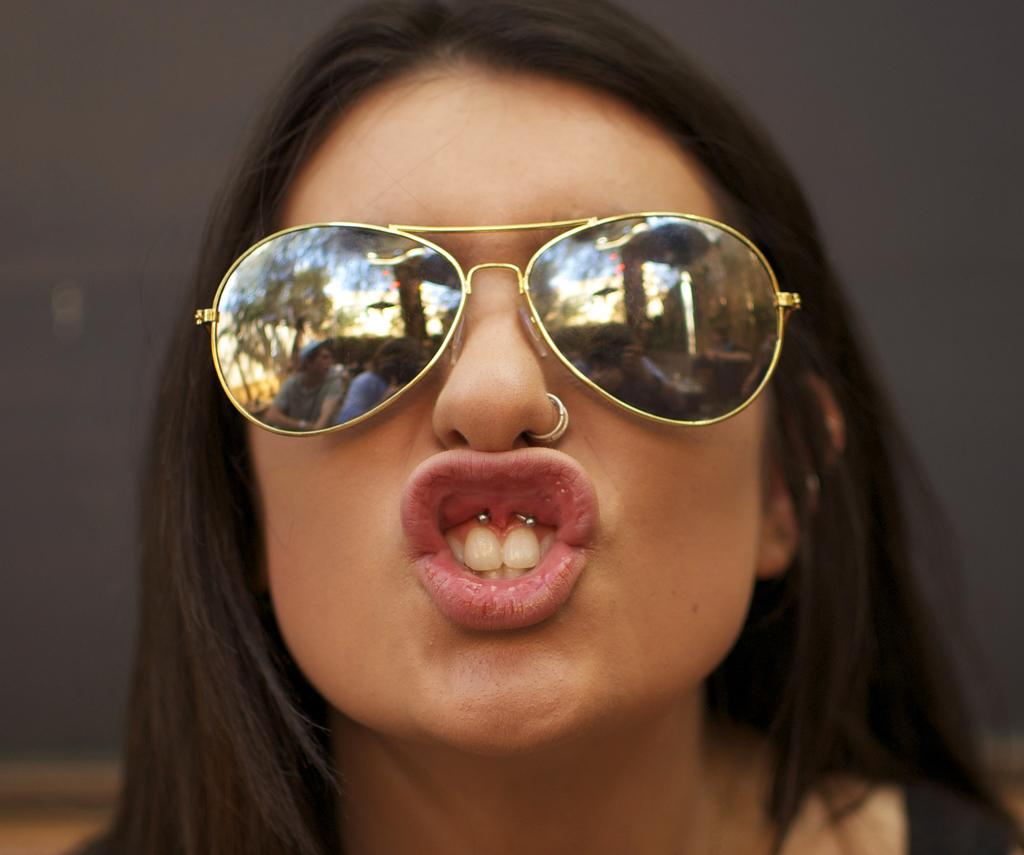Who is the main subject in the image? There is a woman in the image. What is the woman wearing on her face? The woman is wearing goggles. Can you describe any unique features of the woman's appearance? There are two studs on the woman's lips. What year is depicted in the image? There is no specific year depicted in the image; it is a photograph of a woman wearing goggles and lip studs. Can you see any bones in the image? There are no bones visible in the image. 